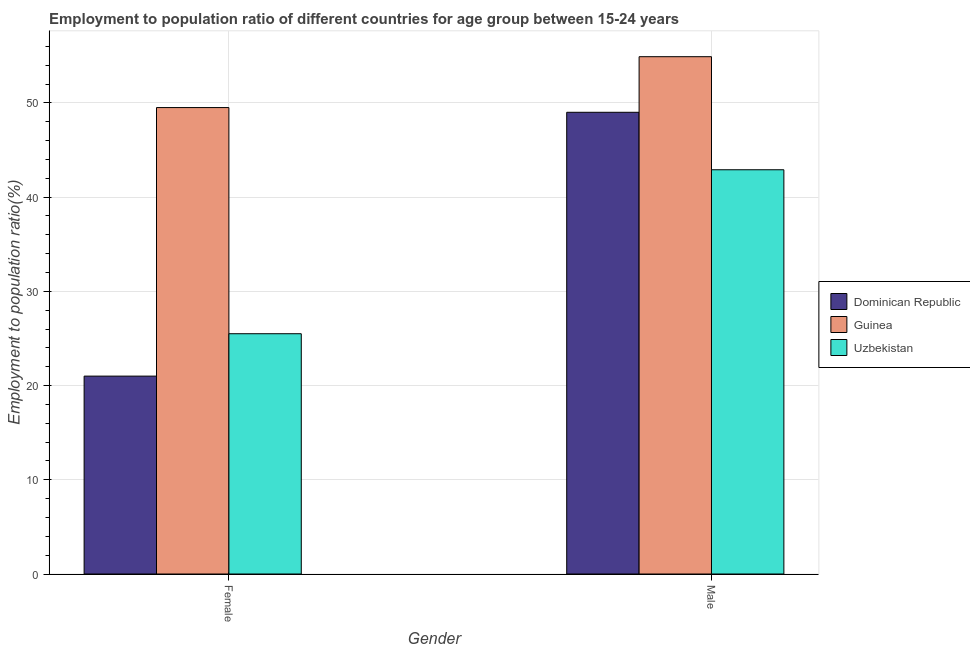How many groups of bars are there?
Provide a succinct answer. 2. What is the label of the 2nd group of bars from the left?
Offer a very short reply. Male. What is the employment to population ratio(male) in Dominican Republic?
Offer a very short reply. 49. Across all countries, what is the maximum employment to population ratio(female)?
Offer a terse response. 49.5. Across all countries, what is the minimum employment to population ratio(female)?
Keep it short and to the point. 21. In which country was the employment to population ratio(female) maximum?
Your answer should be compact. Guinea. In which country was the employment to population ratio(male) minimum?
Your response must be concise. Uzbekistan. What is the total employment to population ratio(female) in the graph?
Your answer should be very brief. 96. What is the difference between the employment to population ratio(male) in Uzbekistan and that in Guinea?
Keep it short and to the point. -12. What is the difference between the employment to population ratio(female) in Dominican Republic and the employment to population ratio(male) in Guinea?
Give a very brief answer. -33.9. What is the average employment to population ratio(male) per country?
Provide a succinct answer. 48.93. What is the difference between the employment to population ratio(female) and employment to population ratio(male) in Uzbekistan?
Keep it short and to the point. -17.4. In how many countries, is the employment to population ratio(female) greater than 36 %?
Offer a terse response. 1. What is the ratio of the employment to population ratio(female) in Uzbekistan to that in Dominican Republic?
Make the answer very short. 1.21. Is the employment to population ratio(male) in Guinea less than that in Uzbekistan?
Offer a very short reply. No. What does the 3rd bar from the left in Male represents?
Your answer should be very brief. Uzbekistan. What does the 3rd bar from the right in Female represents?
Your answer should be very brief. Dominican Republic. How many bars are there?
Your answer should be compact. 6. What is the difference between two consecutive major ticks on the Y-axis?
Give a very brief answer. 10. Are the values on the major ticks of Y-axis written in scientific E-notation?
Your answer should be compact. No. Where does the legend appear in the graph?
Give a very brief answer. Center right. How are the legend labels stacked?
Provide a succinct answer. Vertical. What is the title of the graph?
Your answer should be compact. Employment to population ratio of different countries for age group between 15-24 years. What is the label or title of the X-axis?
Your answer should be compact. Gender. What is the label or title of the Y-axis?
Keep it short and to the point. Employment to population ratio(%). What is the Employment to population ratio(%) in Dominican Republic in Female?
Give a very brief answer. 21. What is the Employment to population ratio(%) in Guinea in Female?
Your answer should be very brief. 49.5. What is the Employment to population ratio(%) of Guinea in Male?
Your answer should be compact. 54.9. What is the Employment to population ratio(%) of Uzbekistan in Male?
Your response must be concise. 42.9. Across all Gender, what is the maximum Employment to population ratio(%) of Guinea?
Offer a very short reply. 54.9. Across all Gender, what is the maximum Employment to population ratio(%) in Uzbekistan?
Give a very brief answer. 42.9. Across all Gender, what is the minimum Employment to population ratio(%) in Guinea?
Your answer should be very brief. 49.5. Across all Gender, what is the minimum Employment to population ratio(%) of Uzbekistan?
Ensure brevity in your answer.  25.5. What is the total Employment to population ratio(%) of Dominican Republic in the graph?
Give a very brief answer. 70. What is the total Employment to population ratio(%) of Guinea in the graph?
Offer a terse response. 104.4. What is the total Employment to population ratio(%) of Uzbekistan in the graph?
Your answer should be very brief. 68.4. What is the difference between the Employment to population ratio(%) in Uzbekistan in Female and that in Male?
Provide a succinct answer. -17.4. What is the difference between the Employment to population ratio(%) of Dominican Republic in Female and the Employment to population ratio(%) of Guinea in Male?
Your answer should be compact. -33.9. What is the difference between the Employment to population ratio(%) in Dominican Republic in Female and the Employment to population ratio(%) in Uzbekistan in Male?
Provide a succinct answer. -21.9. What is the average Employment to population ratio(%) of Dominican Republic per Gender?
Your answer should be compact. 35. What is the average Employment to population ratio(%) in Guinea per Gender?
Provide a succinct answer. 52.2. What is the average Employment to population ratio(%) of Uzbekistan per Gender?
Offer a very short reply. 34.2. What is the difference between the Employment to population ratio(%) of Dominican Republic and Employment to population ratio(%) of Guinea in Female?
Make the answer very short. -28.5. What is the difference between the Employment to population ratio(%) in Guinea and Employment to population ratio(%) in Uzbekistan in Female?
Your response must be concise. 24. What is the ratio of the Employment to population ratio(%) in Dominican Republic in Female to that in Male?
Your response must be concise. 0.43. What is the ratio of the Employment to population ratio(%) in Guinea in Female to that in Male?
Ensure brevity in your answer.  0.9. What is the ratio of the Employment to population ratio(%) in Uzbekistan in Female to that in Male?
Offer a very short reply. 0.59. What is the difference between the highest and the second highest Employment to population ratio(%) of Dominican Republic?
Provide a succinct answer. 28. What is the difference between the highest and the second highest Employment to population ratio(%) in Guinea?
Your answer should be very brief. 5.4. What is the difference between the highest and the second highest Employment to population ratio(%) of Uzbekistan?
Provide a succinct answer. 17.4. What is the difference between the highest and the lowest Employment to population ratio(%) in Guinea?
Offer a very short reply. 5.4. 